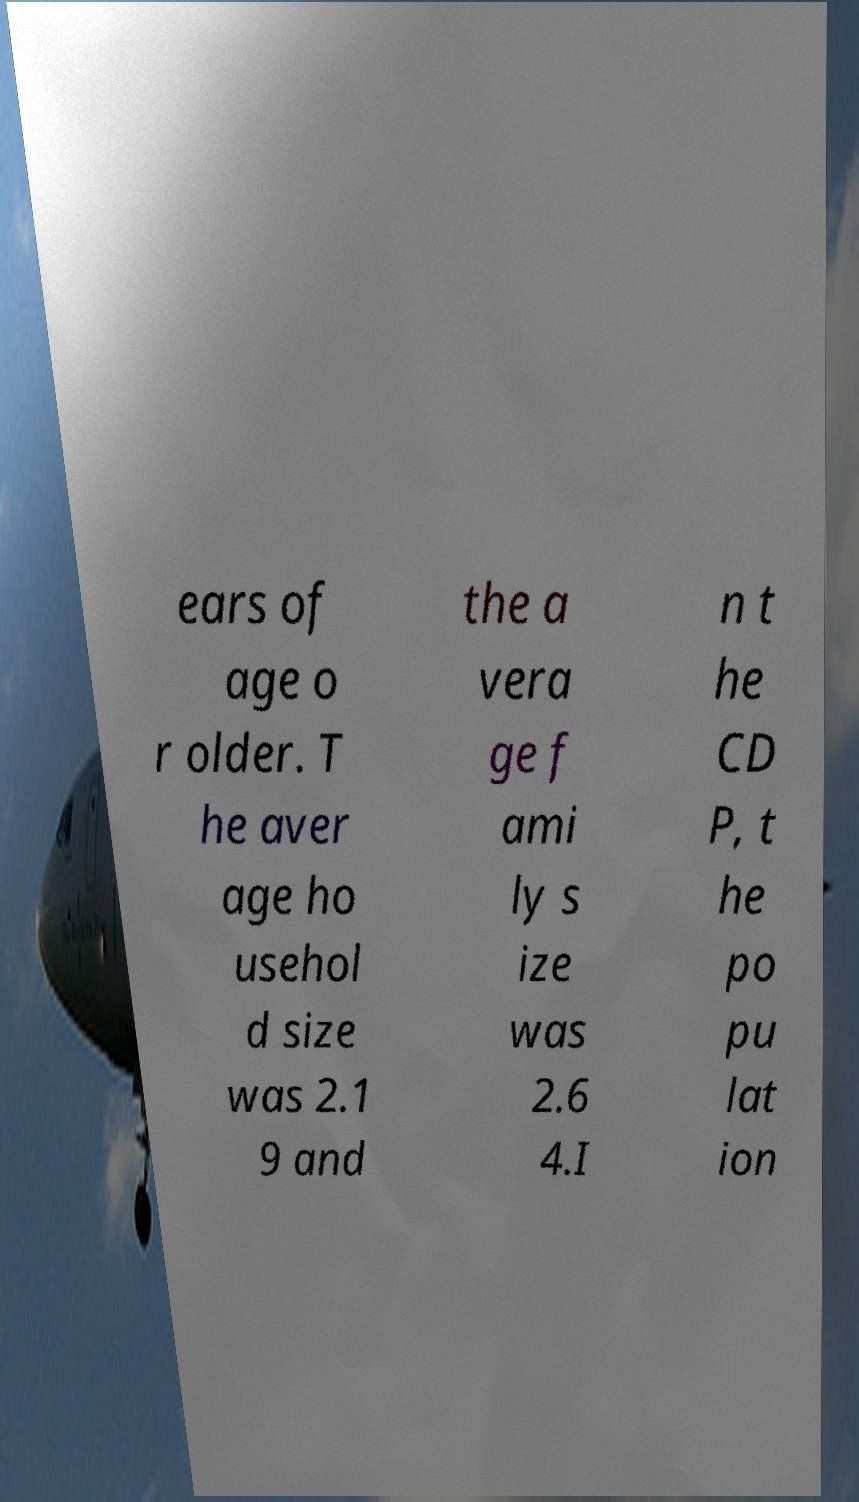Can you accurately transcribe the text from the provided image for me? ears of age o r older. T he aver age ho usehol d size was 2.1 9 and the a vera ge f ami ly s ize was 2.6 4.I n t he CD P, t he po pu lat ion 